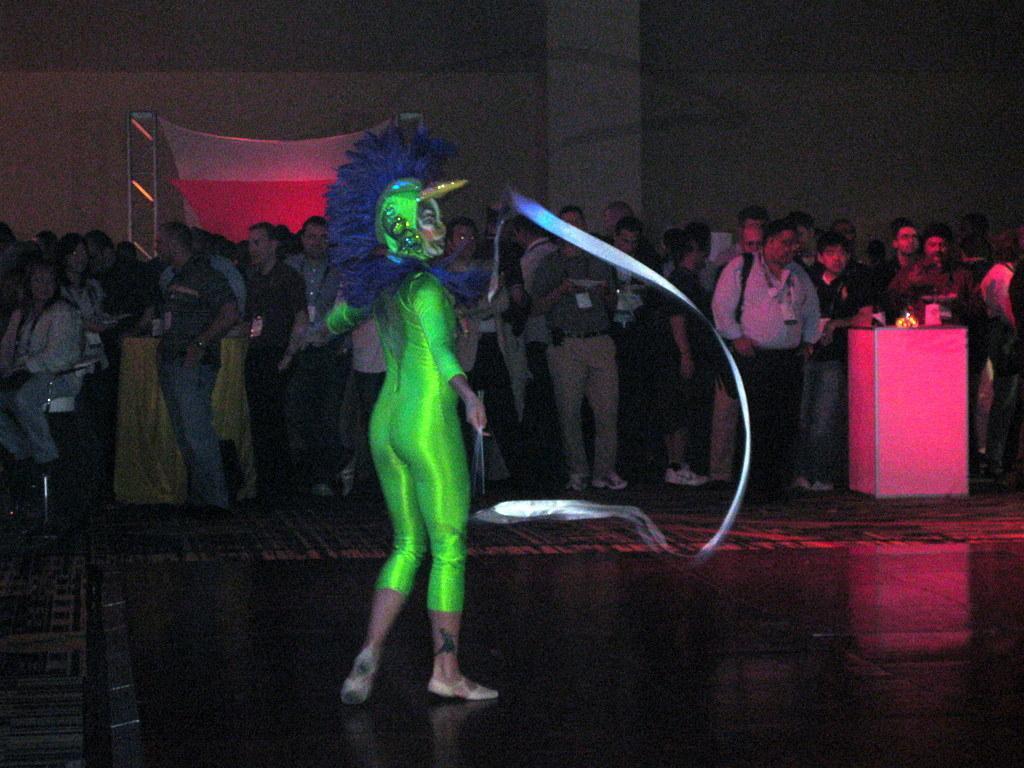Describe this image in one or two sentences. In this image we can see a woman wearing a costume standing on the floor holding a ribbon stick. On the backside we can see a group of people standing. We can also see a speaker stand, the flag to a pole and a wall. 